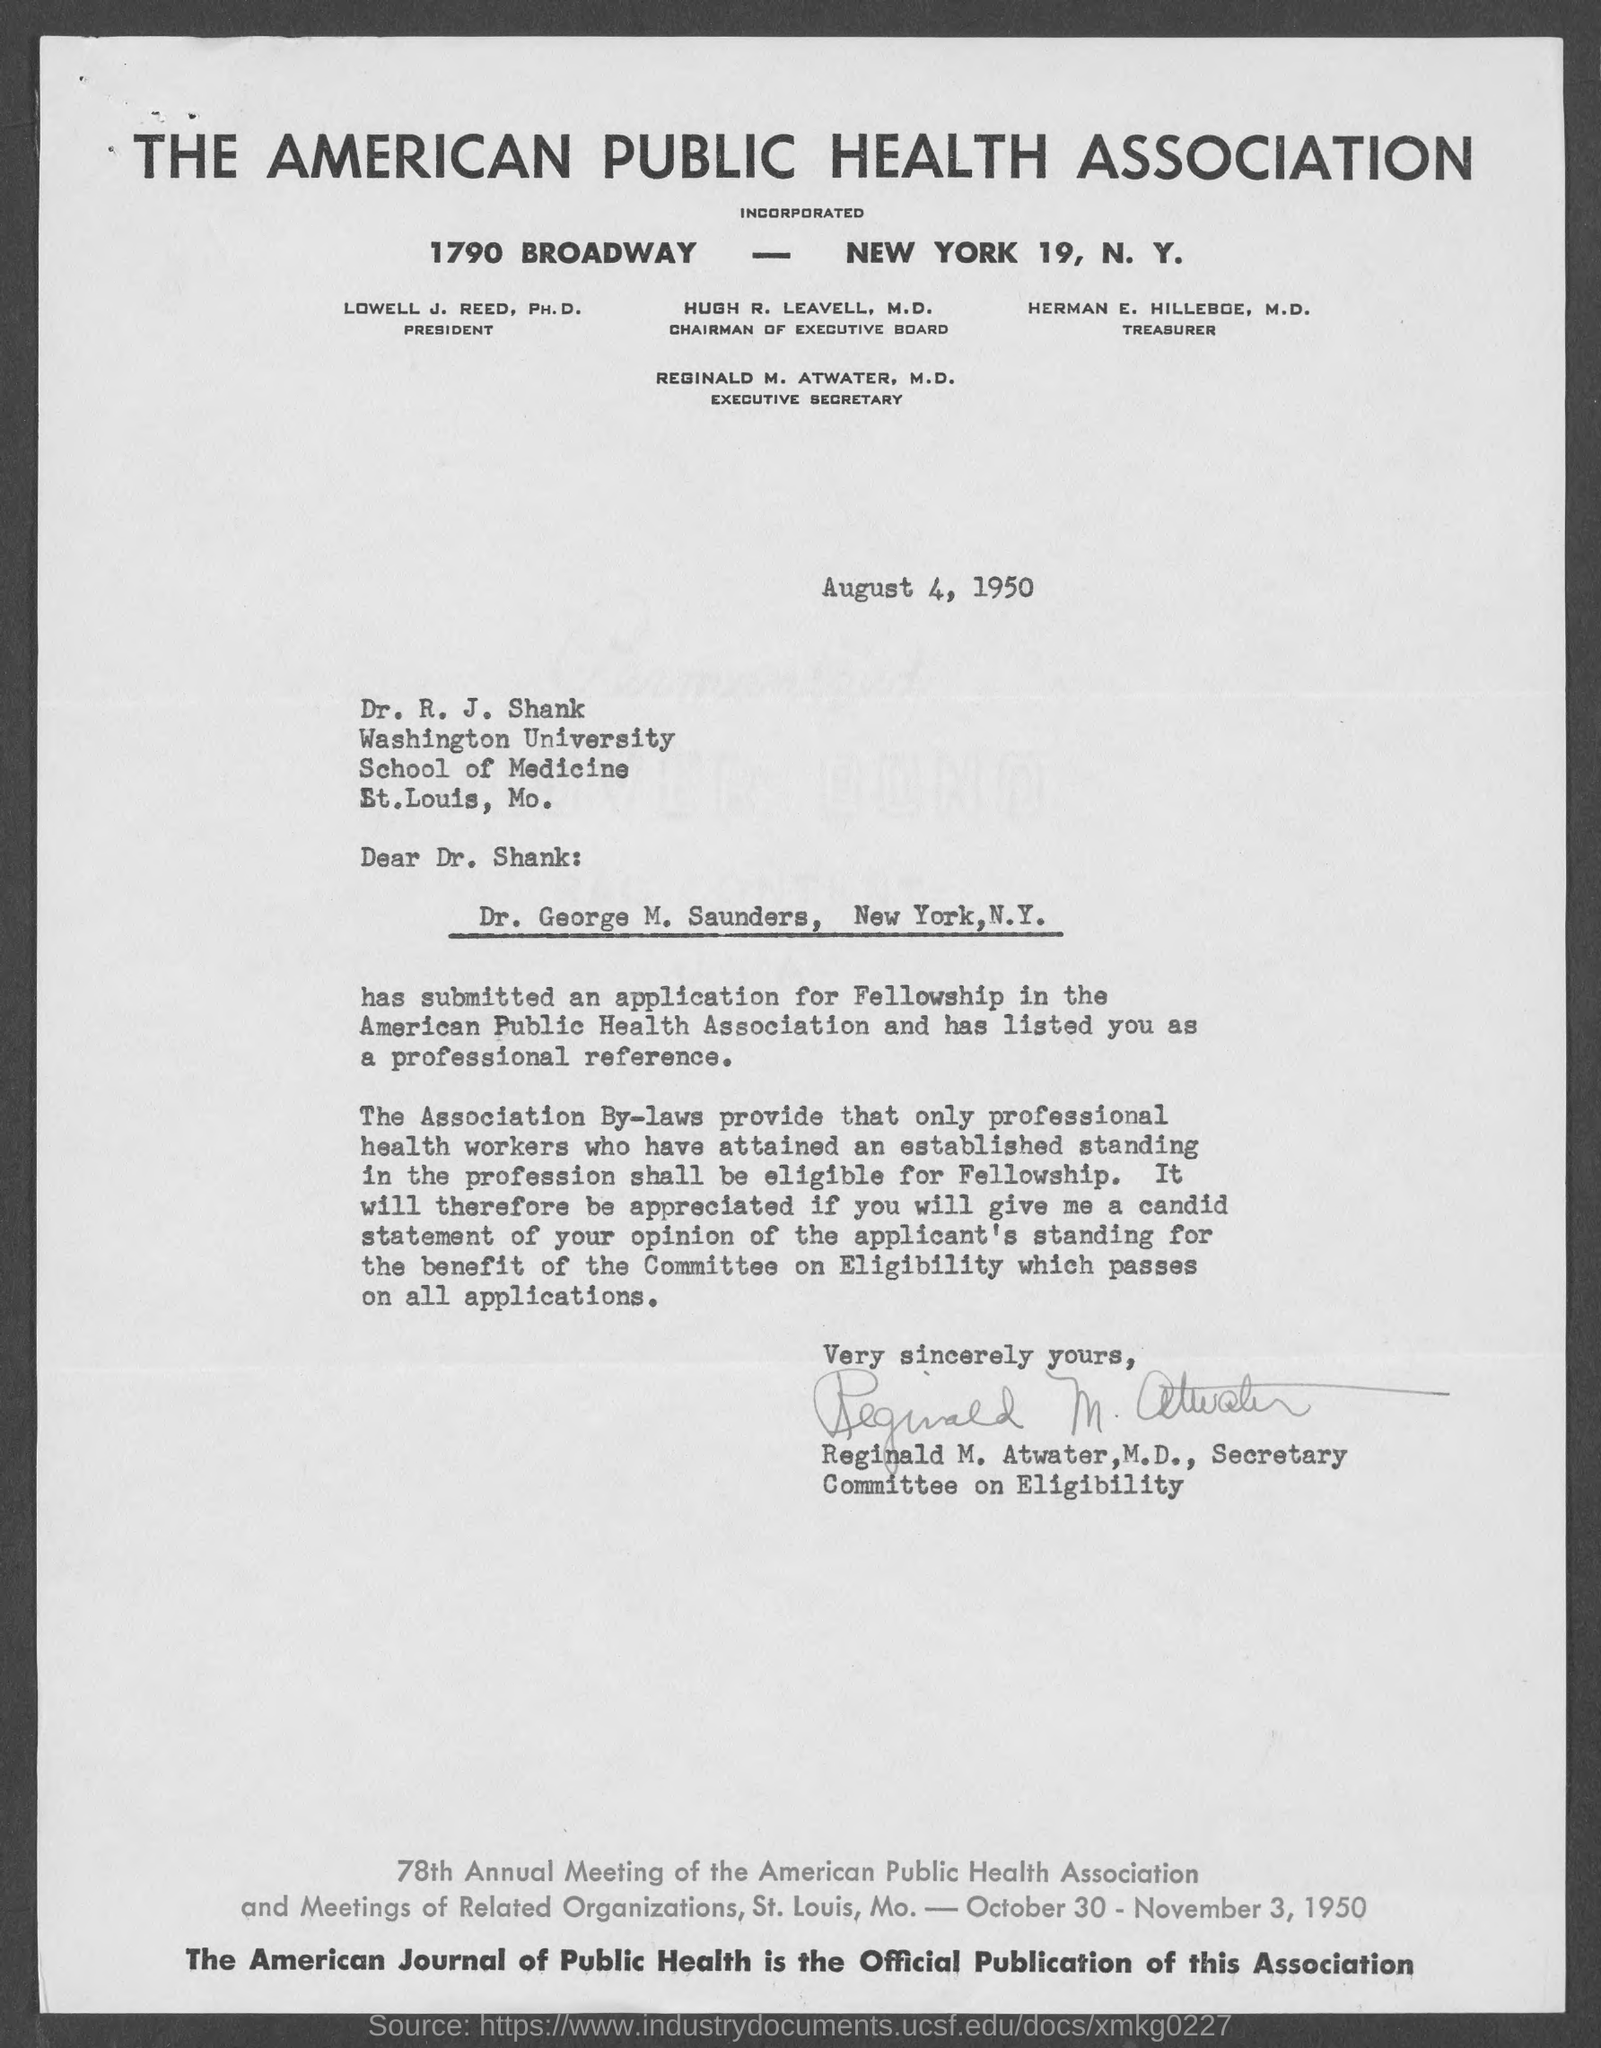What is the name of health association given ?
Provide a succinct answer. The American Public Health Association. What is the address of the american public health association?
Provide a short and direct response. 1790 Broadway, New York 19, N.Y. Who is the chairman of executive board ?
Offer a terse response. Hugh R. Leavell, M.D. Who is the executive secretary of the american public health association ?
Provide a short and direct response. Reginald M. Atwater,  M.D,. Who is the Treasurer of the American Public Health Association?
Your answer should be very brief. Herman E. Hilleboe, M.D. What is the date letter is written on?
Keep it short and to the point. August 4, 1950. What is the address of washington university, school of medicine?
Offer a terse response. St. Louis, Mo. Who wrote this letter?
Make the answer very short. Reginald M. Atwater, M.D., Secretary. What is the name of official publication of this association ?
Ensure brevity in your answer.  The American Journal of Public Health. 